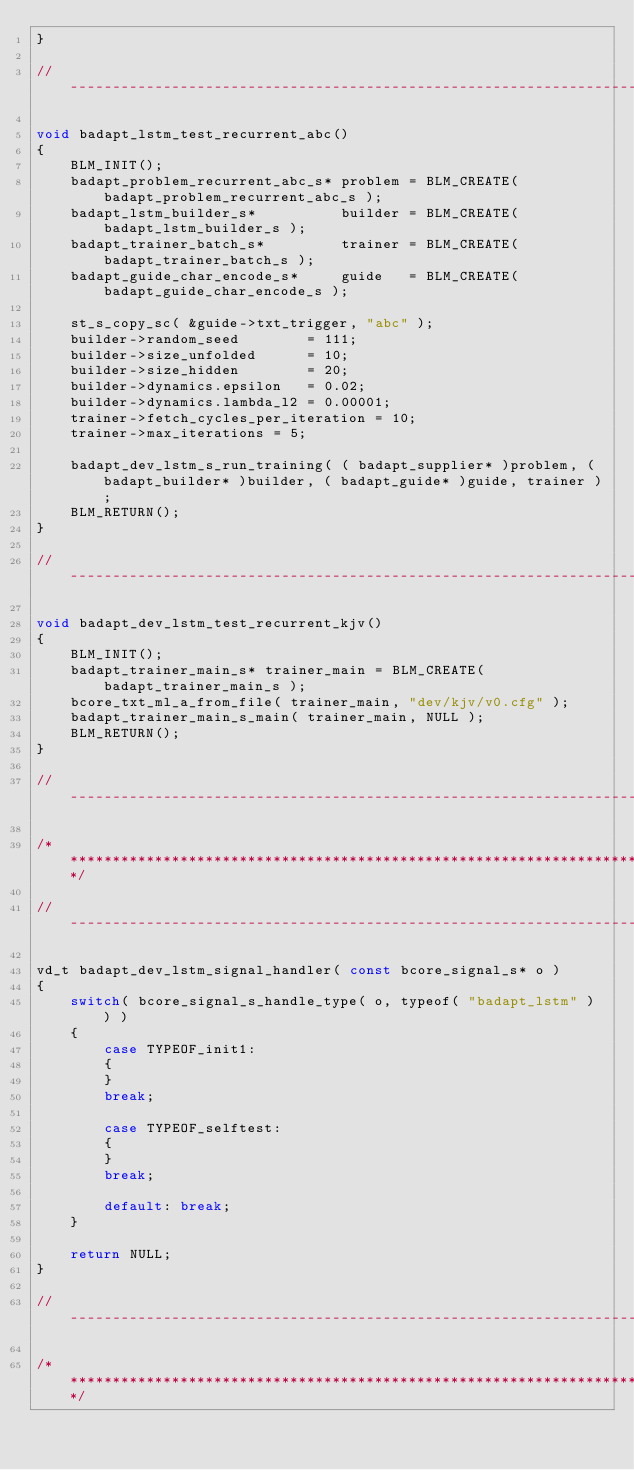<code> <loc_0><loc_0><loc_500><loc_500><_C_>}

// ---------------------------------------------------------------------------------------------------------------------

void badapt_lstm_test_recurrent_abc()
{
    BLM_INIT();
    badapt_problem_recurrent_abc_s* problem = BLM_CREATE( badapt_problem_recurrent_abc_s );
    badapt_lstm_builder_s*          builder = BLM_CREATE( badapt_lstm_builder_s );
    badapt_trainer_batch_s*         trainer = BLM_CREATE( badapt_trainer_batch_s );
    badapt_guide_char_encode_s*     guide   = BLM_CREATE( badapt_guide_char_encode_s );

    st_s_copy_sc( &guide->txt_trigger, "abc" );
    builder->random_seed        = 111;
    builder->size_unfolded      = 10;
    builder->size_hidden        = 20;
    builder->dynamics.epsilon   = 0.02;
    builder->dynamics.lambda_l2 = 0.00001;
    trainer->fetch_cycles_per_iteration = 10;
    trainer->max_iterations = 5;

    badapt_dev_lstm_s_run_training( ( badapt_supplier* )problem, ( badapt_builder* )builder, ( badapt_guide* )guide, trainer );
    BLM_RETURN();
}

// ---------------------------------------------------------------------------------------------------------------------

void badapt_dev_lstm_test_recurrent_kjv()
{
    BLM_INIT();
    badapt_trainer_main_s* trainer_main = BLM_CREATE( badapt_trainer_main_s );
    bcore_txt_ml_a_from_file( trainer_main, "dev/kjv/v0.cfg" );
    badapt_trainer_main_s_main( trainer_main, NULL );
    BLM_RETURN();
}

// ---------------------------------------------------------------------------------------------------------------------

/**********************************************************************************************************************/

// ---------------------------------------------------------------------------------------------------------------------

vd_t badapt_dev_lstm_signal_handler( const bcore_signal_s* o )
{
    switch( bcore_signal_s_handle_type( o, typeof( "badapt_lstm" ) ) )
    {
        case TYPEOF_init1:
        {
        }
        break;

        case TYPEOF_selftest:
        {
        }
        break;

        default: break;
    }

    return NULL;
}

// ---------------------------------------------------------------------------------------------------------------------

/**********************************************************************************************************************/


</code> 